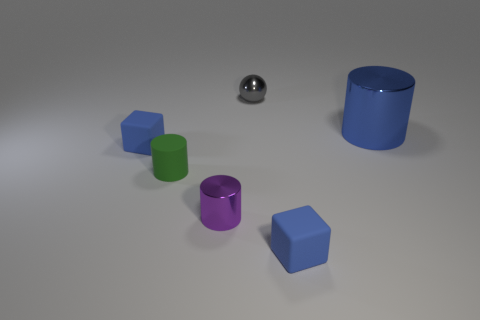What can you infer about the purpose of this arrangement? The arrangement of the objects might be for a comparative study of shapes, materials, and shadows. It could be an educational setup to learn about geometry, reflectivity of surfaces, and how light interacts with different materials. Are the shapes arranged in any specific pattern? The shapes are not arranged in a recognizable pattern. They seem to be placed randomly across the surface. However, this scattered placement can help in comparing and contrasting the objects independently of each other. 